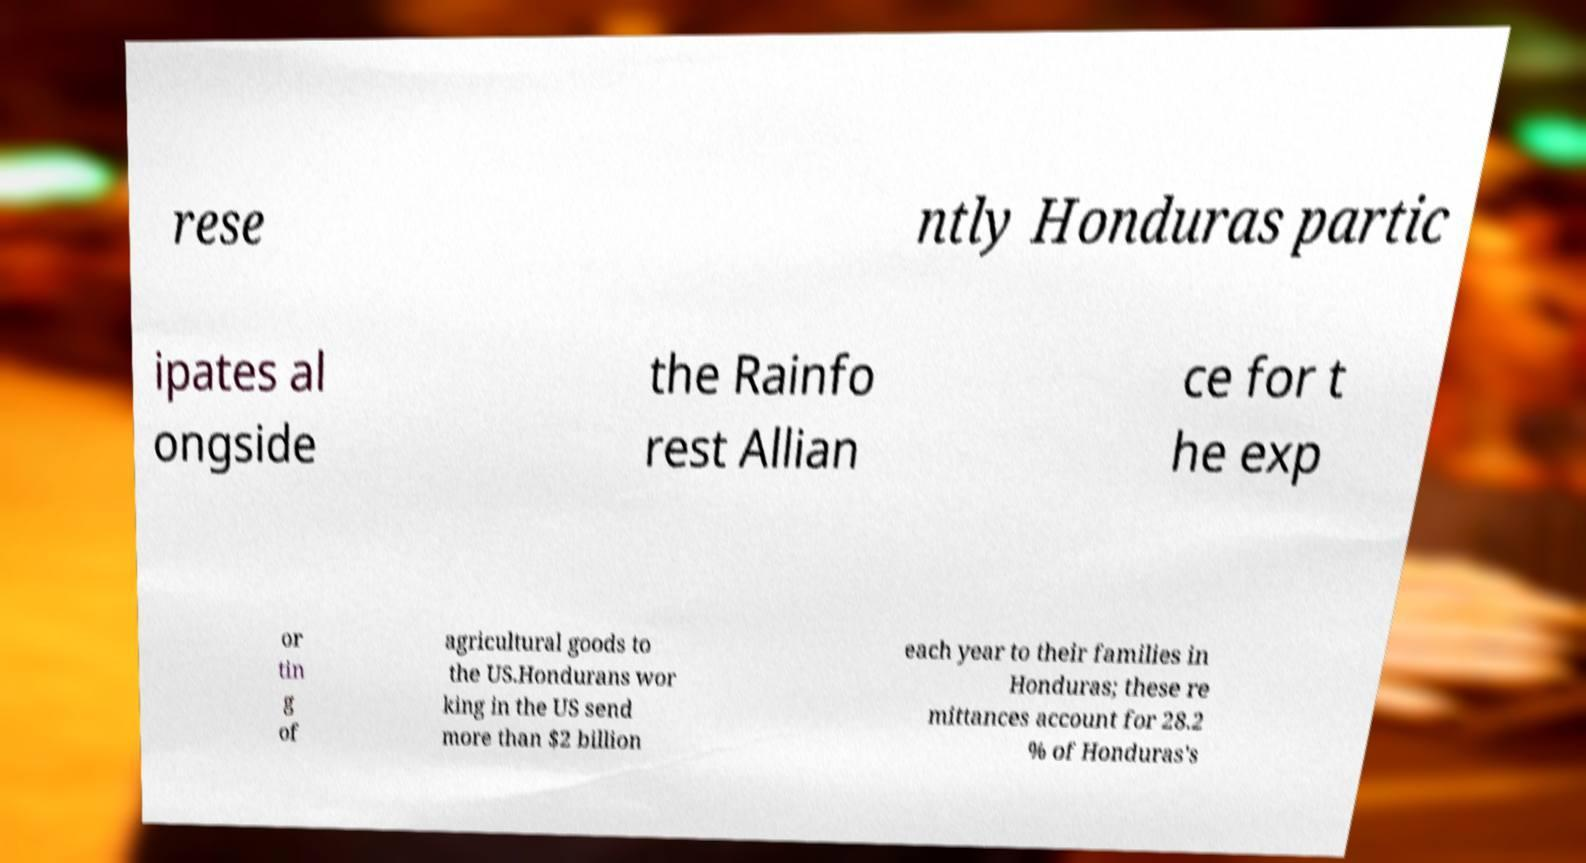What messages or text are displayed in this image? I need them in a readable, typed format. rese ntly Honduras partic ipates al ongside the Rainfo rest Allian ce for t he exp or tin g of agricultural goods to the US.Hondurans wor king in the US send more than $2 billion each year to their families in Honduras; these re mittances account for 28.2 % of Honduras's 